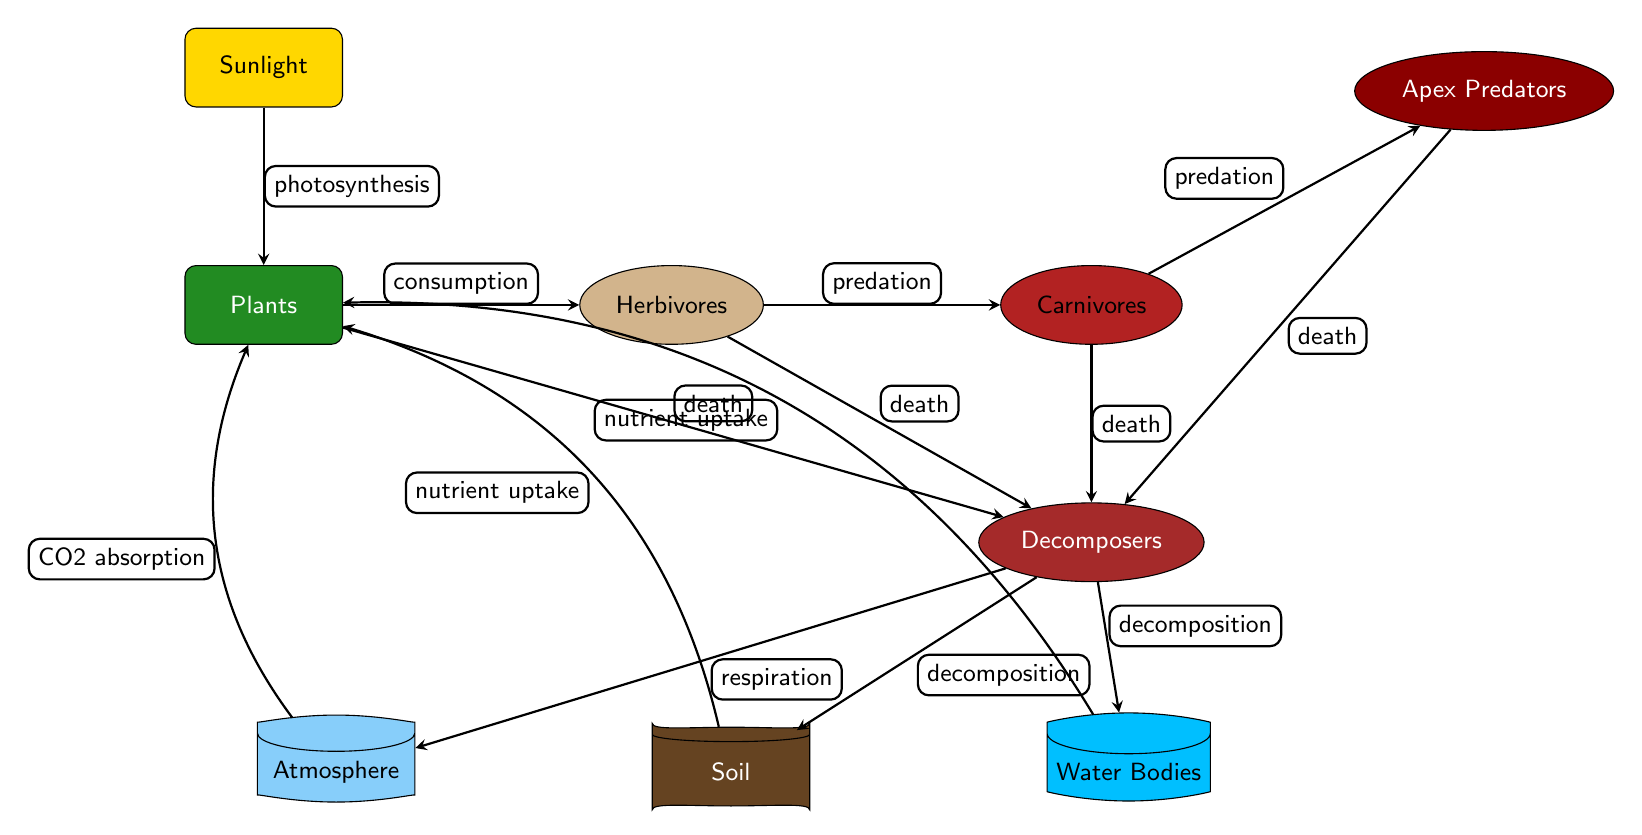What is the role of plants in this food chain? In the diagram, plants are depicted as the primary producers that utilize sunlight for photosynthesis. They are the base of the food chain, providing energy directly to herbivores through consumption.
Answer: Producers How many types of consumers are shown in the diagram? There are four types of consumers represented: herbivores, carnivores, apex predators, and decomposers. Each of these consumers occupies a different level in the food chain, reflecting their role in energy transfer.
Answer: Four What process connects sunlight and plants? The diagram illustrates that the process linking sunlight to plants is photosynthesis. This process allows plants to convert sunlight into chemical energy.
Answer: Photosynthesis What happens to organisms after death in this cycle? According to the diagram, all organisms (apex predators, carnivores, herbivores, and plants) contribute to the decomposers after death. The decomposers are responsible for breaking down the organic matter, returning nutrients to the ecosystem.
Answer: Decomposition Which reservoir is connected to the atmosphere in the cycle? The atmosphere is connected to the cycle through respiration from decomposers. This process releases carbon dioxide back into the atmosphere, integrating the biological and chemical cycles.
Answer: Atmosphere How do plants acquire nutrients in this diagram? Plants obtain nutrients by uptaking them from the soil, as indicated by the nutrient uptake arrows leading to the plants from the soil reservoir. Additionally, they also absorb carbon dioxide from the atmosphere during photosynthesis.
Answer: Nutrient uptake What are the three main reservoirs depicted in the food chain? The food chain diagram portrays three main reservoirs: soil, atmosphere, and water bodies. These reservoirs play a crucial role in nutrient cycling and supporting the various life forms in the ecosystem.
Answer: Soil, Atmosphere, Water Bodies How is energy transferred from herbivores to carnivores? The transfer of energy from herbivores to carnivores occurs through predation. When carnivores consume herbivores, they assimilate the energy stored in the herbivores' bodies, which is represented by the arrow labeled predation.
Answer: Predation What is the final decomposition product of decomposers? Decomposers break down dead organic matter, resulting in nutrient-rich soil, carbon dioxide released into the atmosphere, and nutrients transferring back into water bodies. The diagram shows these connections clearly.
Answer: Soil 